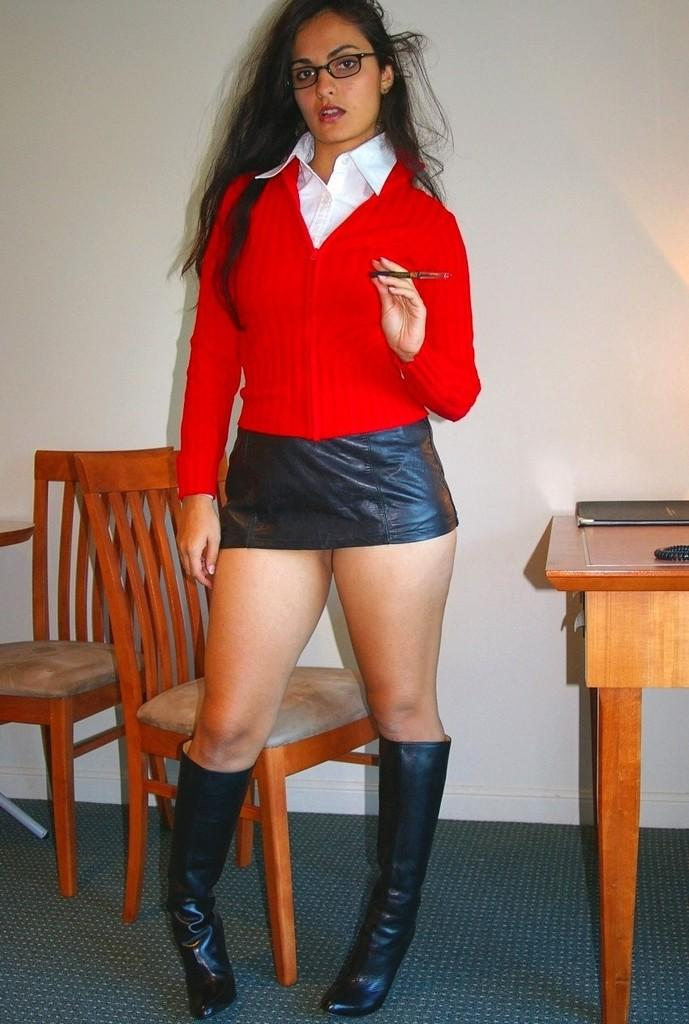Who is present in the image? There is a woman in the image. What is the woman doing in the image? The woman is standing. What object is the woman holding in the image? The woman is holding a pen. What furniture can be seen behind the woman? There are chairs behind the woman. What is the main piece of furniture in the image? There is a table in the image. What items are on the table? There are books on the table. What is visible in the background of the image? There is a wall visible in the image. What type of fowl can be seen on the woman's shoulder in the image? There is no fowl present on the woman's shoulder in the image. What advice might the woman's dad give her in the image? There is no indication of the woman's dad being present in the image, so it's not possible to determine what advice he might give her. 